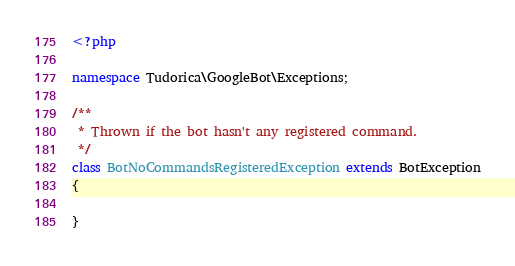<code> <loc_0><loc_0><loc_500><loc_500><_PHP_><?php

namespace Tudorica\GoogleBot\Exceptions;

/**
 * Thrown if the bot hasn't any registered command.
 */
class BotNoCommandsRegisteredException extends BotException
{

}</code> 